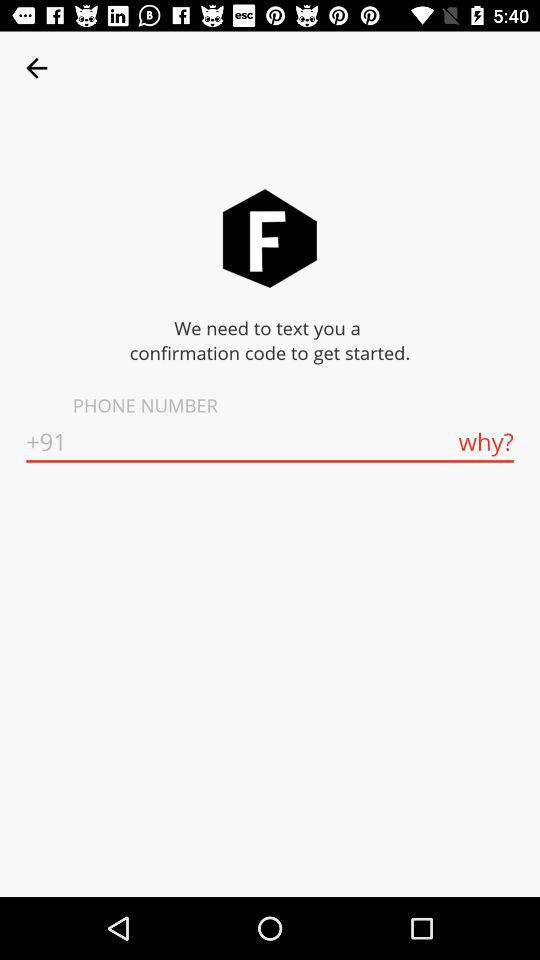What is the country code? The country code is +91. 